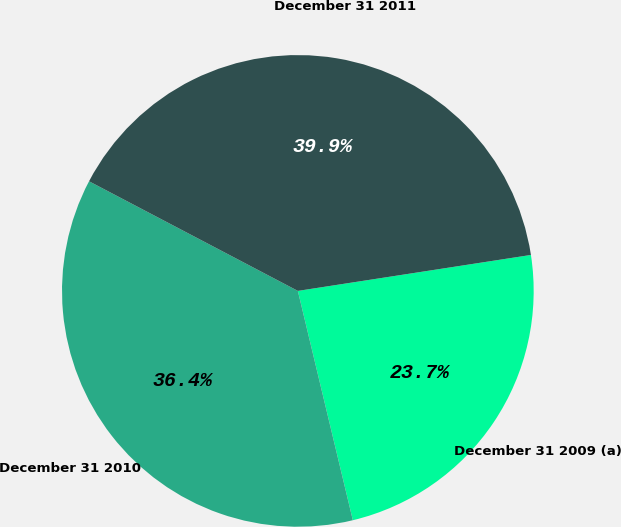Convert chart. <chart><loc_0><loc_0><loc_500><loc_500><pie_chart><fcel>December 31 2009 (a)<fcel>December 31 2010<fcel>December 31 2011<nl><fcel>23.69%<fcel>36.44%<fcel>39.87%<nl></chart> 